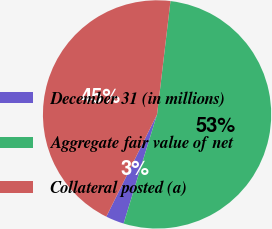Convert chart to OTSL. <chart><loc_0><loc_0><loc_500><loc_500><pie_chart><fcel>December 31 (in millions)<fcel>Aggregate fair value of net<fcel>Collateral posted (a)<nl><fcel>2.6%<fcel>52.86%<fcel>44.54%<nl></chart> 